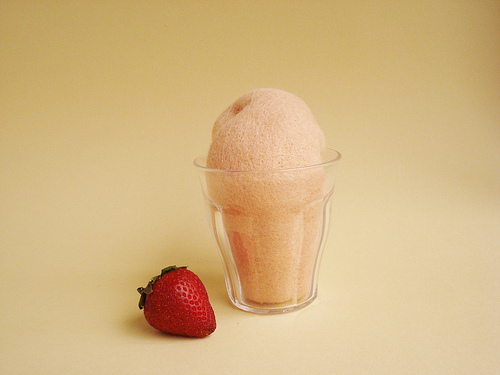<image>
Can you confirm if the strawberry is to the left of the icecream? Yes. From this viewpoint, the strawberry is positioned to the left side relative to the icecream. 